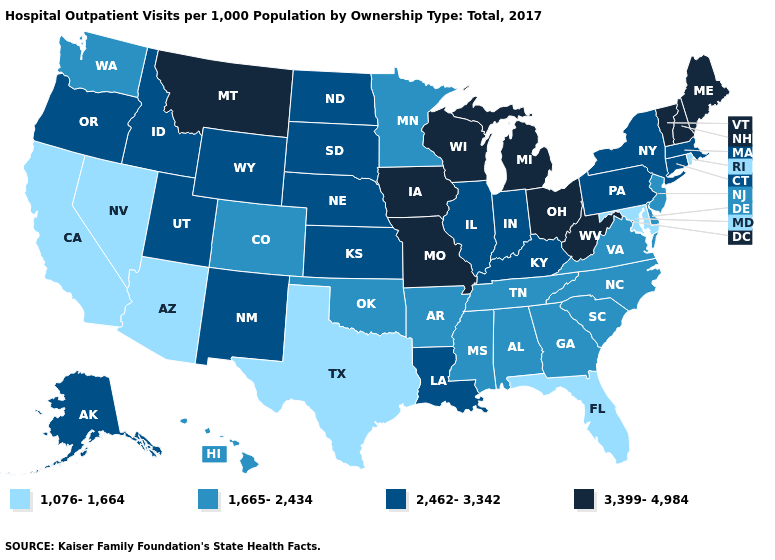Name the states that have a value in the range 2,462-3,342?
Answer briefly. Alaska, Connecticut, Idaho, Illinois, Indiana, Kansas, Kentucky, Louisiana, Massachusetts, Nebraska, New Mexico, New York, North Dakota, Oregon, Pennsylvania, South Dakota, Utah, Wyoming. Which states have the lowest value in the MidWest?
Be succinct. Minnesota. Does Hawaii have the lowest value in the USA?
Concise answer only. No. What is the lowest value in the USA?
Answer briefly. 1,076-1,664. What is the value of Colorado?
Be succinct. 1,665-2,434. Does Utah have the same value as Maine?
Give a very brief answer. No. Does Vermont have the same value as Maryland?
Concise answer only. No. Does Louisiana have the highest value in the USA?
Keep it brief. No. Which states have the lowest value in the USA?
Be succinct. Arizona, California, Florida, Maryland, Nevada, Rhode Island, Texas. Does Indiana have a higher value than Louisiana?
Short answer required. No. What is the value of New York?
Keep it brief. 2,462-3,342. Which states hav the highest value in the South?
Be succinct. West Virginia. Among the states that border Maryland , does Pennsylvania have the lowest value?
Quick response, please. No. Among the states that border New Hampshire , which have the lowest value?
Give a very brief answer. Massachusetts. 